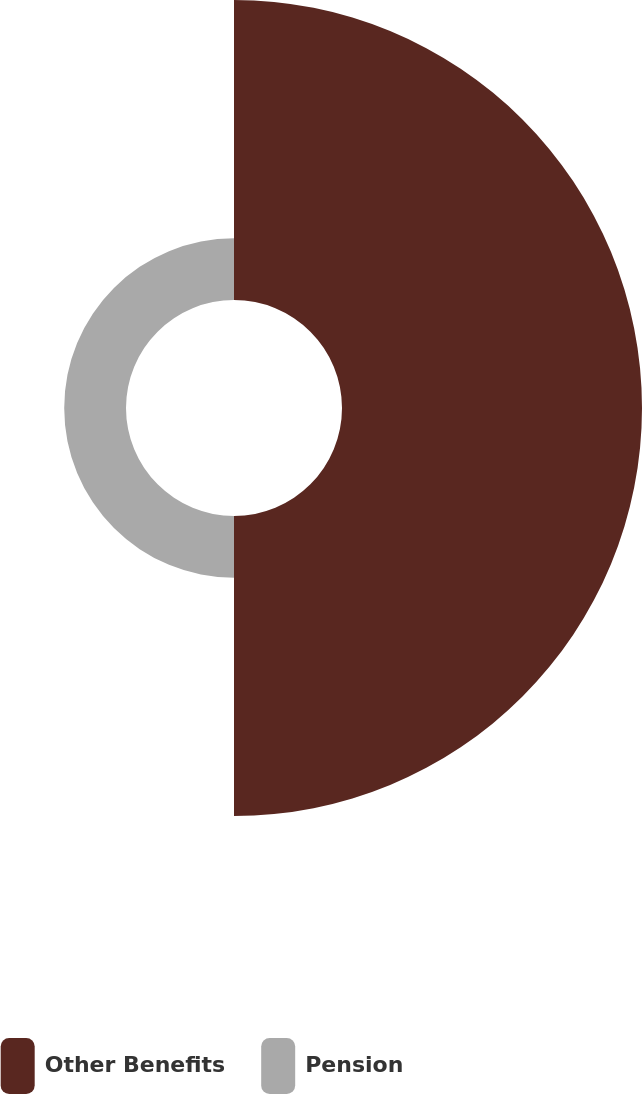Convert chart. <chart><loc_0><loc_0><loc_500><loc_500><pie_chart><fcel>Other Benefits<fcel>Pension<nl><fcel>82.92%<fcel>17.08%<nl></chart> 